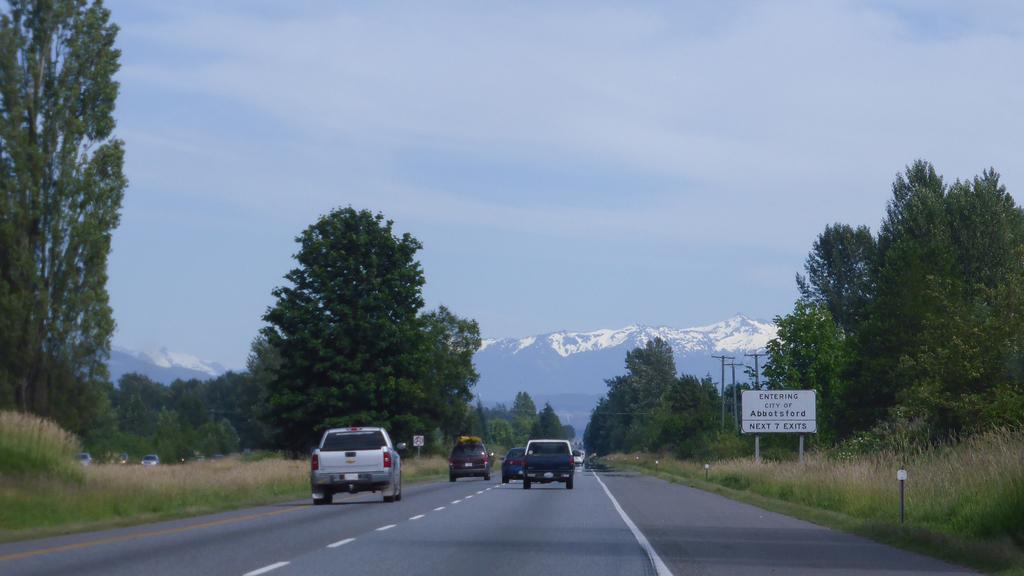What can be seen on the road in the image? There are vehicles on the road in the image. What type of vegetation is present on either side of the road? There are trees on either side of the road in the image. What is visible in the background of the image? There are mountains in the background of the image. What is the condition of the mountains in the image? The mountains are covered with snow. Can you see an ant carrying a pin on the island in the image? There is no island or ant carrying a pin present in the image. 